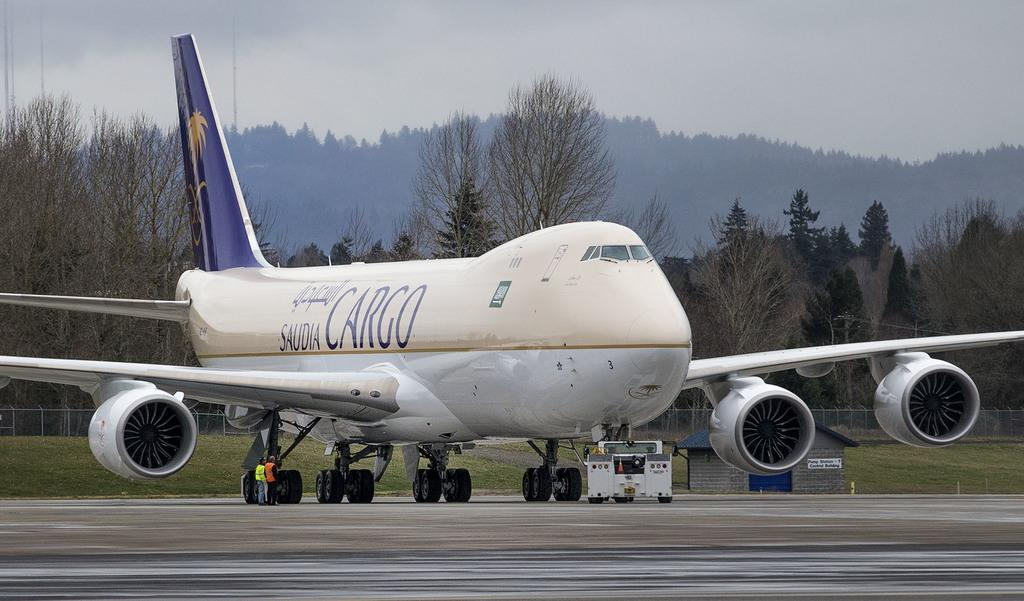<image>
Share a concise interpretation of the image provided. the word cargo is on the side of the plane 